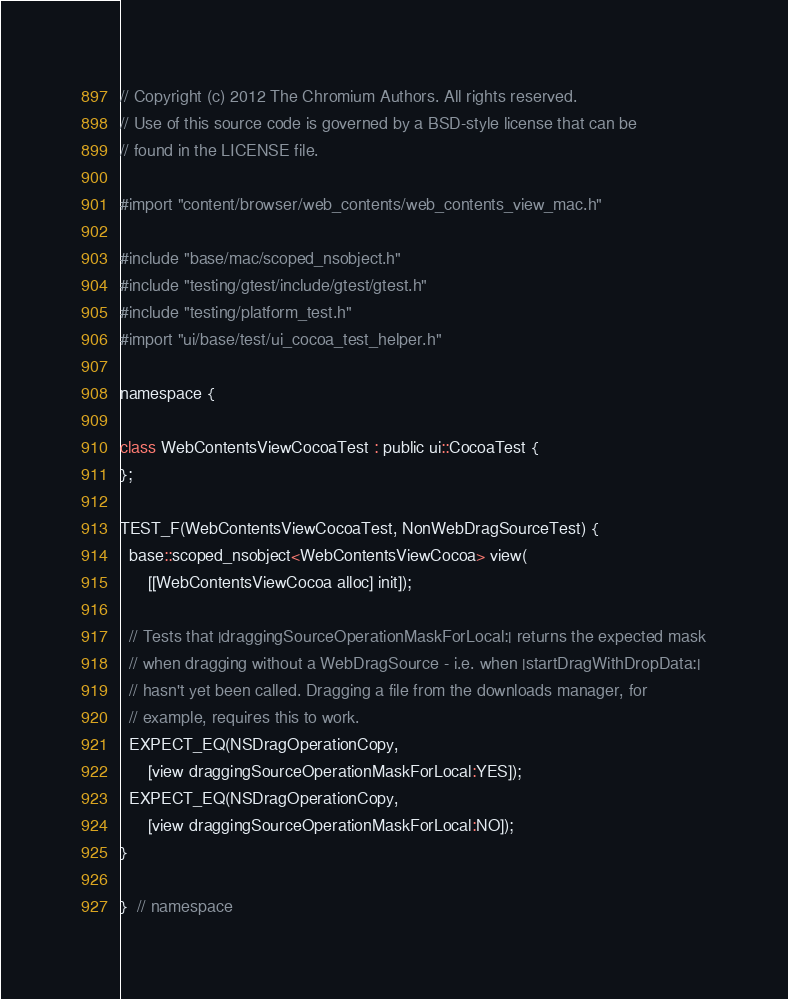Convert code to text. <code><loc_0><loc_0><loc_500><loc_500><_ObjectiveC_>// Copyright (c) 2012 The Chromium Authors. All rights reserved.
// Use of this source code is governed by a BSD-style license that can be
// found in the LICENSE file.

#import "content/browser/web_contents/web_contents_view_mac.h"

#include "base/mac/scoped_nsobject.h"
#include "testing/gtest/include/gtest/gtest.h"
#include "testing/platform_test.h"
#import "ui/base/test/ui_cocoa_test_helper.h"

namespace {

class WebContentsViewCocoaTest : public ui::CocoaTest {
};

TEST_F(WebContentsViewCocoaTest, NonWebDragSourceTest) {
  base::scoped_nsobject<WebContentsViewCocoa> view(
      [[WebContentsViewCocoa alloc] init]);

  // Tests that |draggingSourceOperationMaskForLocal:| returns the expected mask
  // when dragging without a WebDragSource - i.e. when |startDragWithDropData:|
  // hasn't yet been called. Dragging a file from the downloads manager, for
  // example, requires this to work.
  EXPECT_EQ(NSDragOperationCopy,
      [view draggingSourceOperationMaskForLocal:YES]);
  EXPECT_EQ(NSDragOperationCopy,
      [view draggingSourceOperationMaskForLocal:NO]);
}

}  // namespace
</code> 